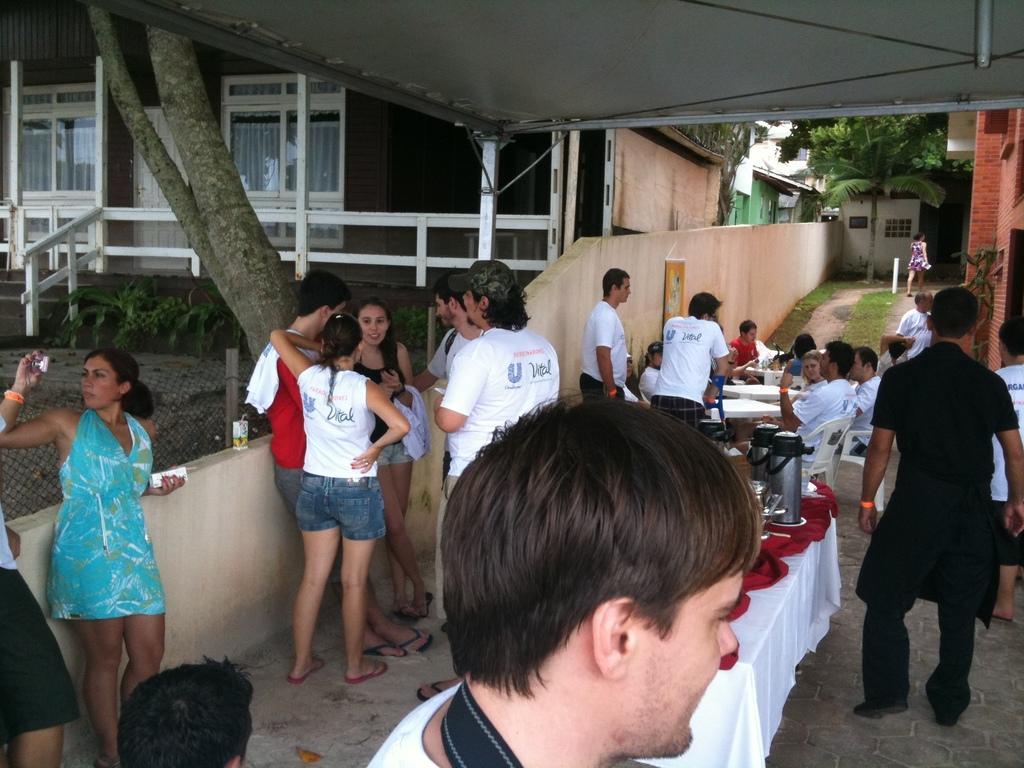Describe this image in one or two sentences. Few people are sitting on chairs and few people standing. We can see kettles and objects on the table and we can see fence and tree trunk. Background we can see wall,glass windows,plants and trees. 